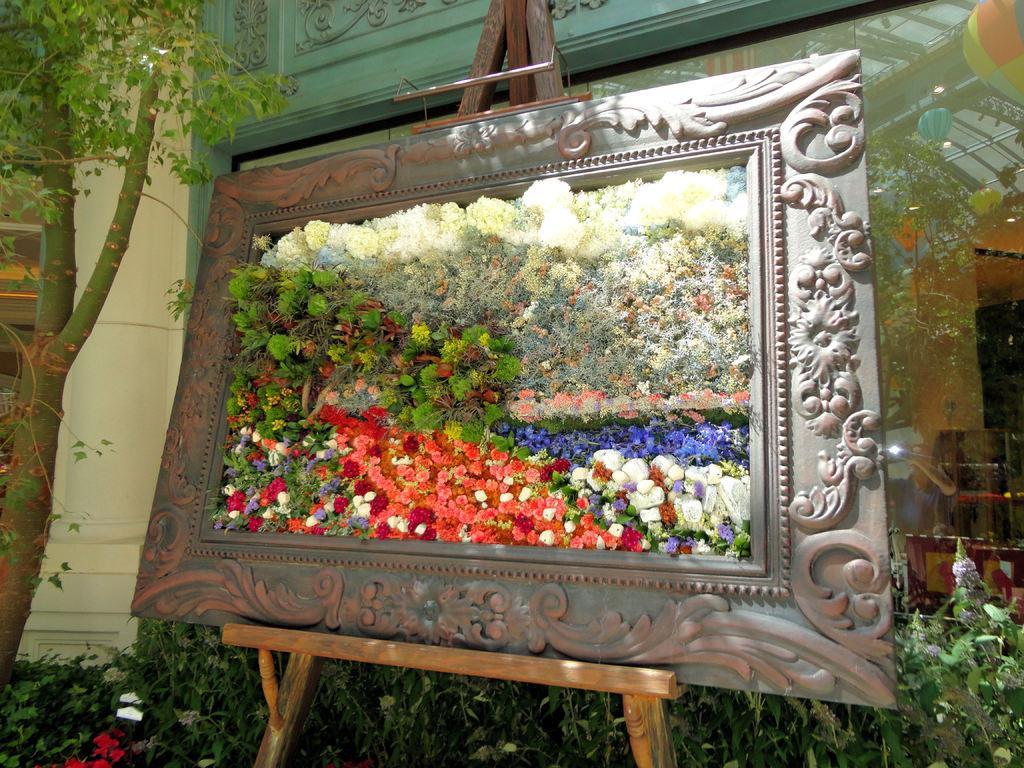Describe this image in one or two sentences. In this image in the center there is one board and there are some flowers. And in the background there is a building and some plants, tree, pillar and some other objects. 